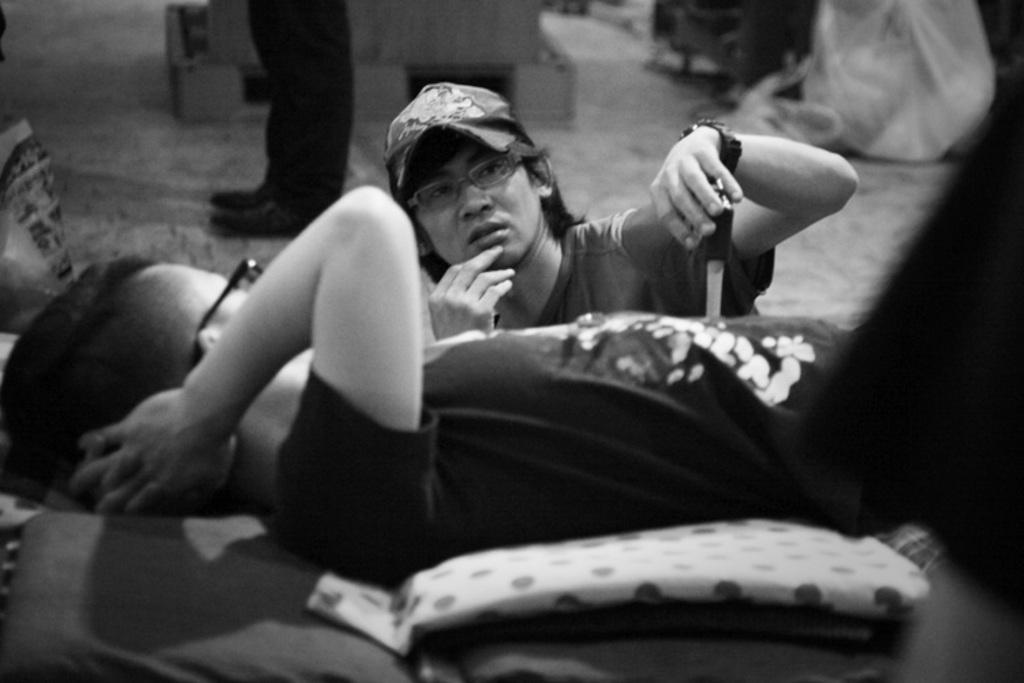How many people are in the image? There are two persons in the foreground of the image. What can be seen at the bottom of the image? There is a floor visible at the bottom of the image. What type of magic is being performed by the persons in the image? There is no indication of magic or any magical activity in the image. 